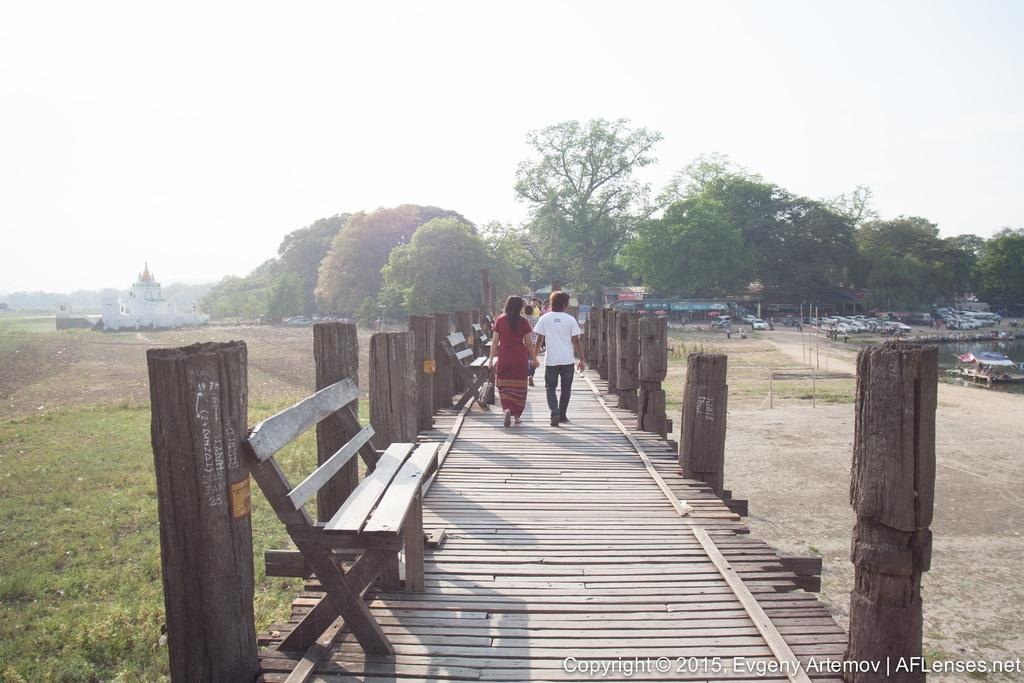What are the people in the image doing? The people in the image are walking on a bridge. What type of structure is present in the image? There is a bench in the image. What type of natural environment is visible in the image? There are trees visible in the image. What type of organization is responsible for maintaining the rhythm of the sand in the image? There is no mention of any organization, rhythm, or sand in the image. 